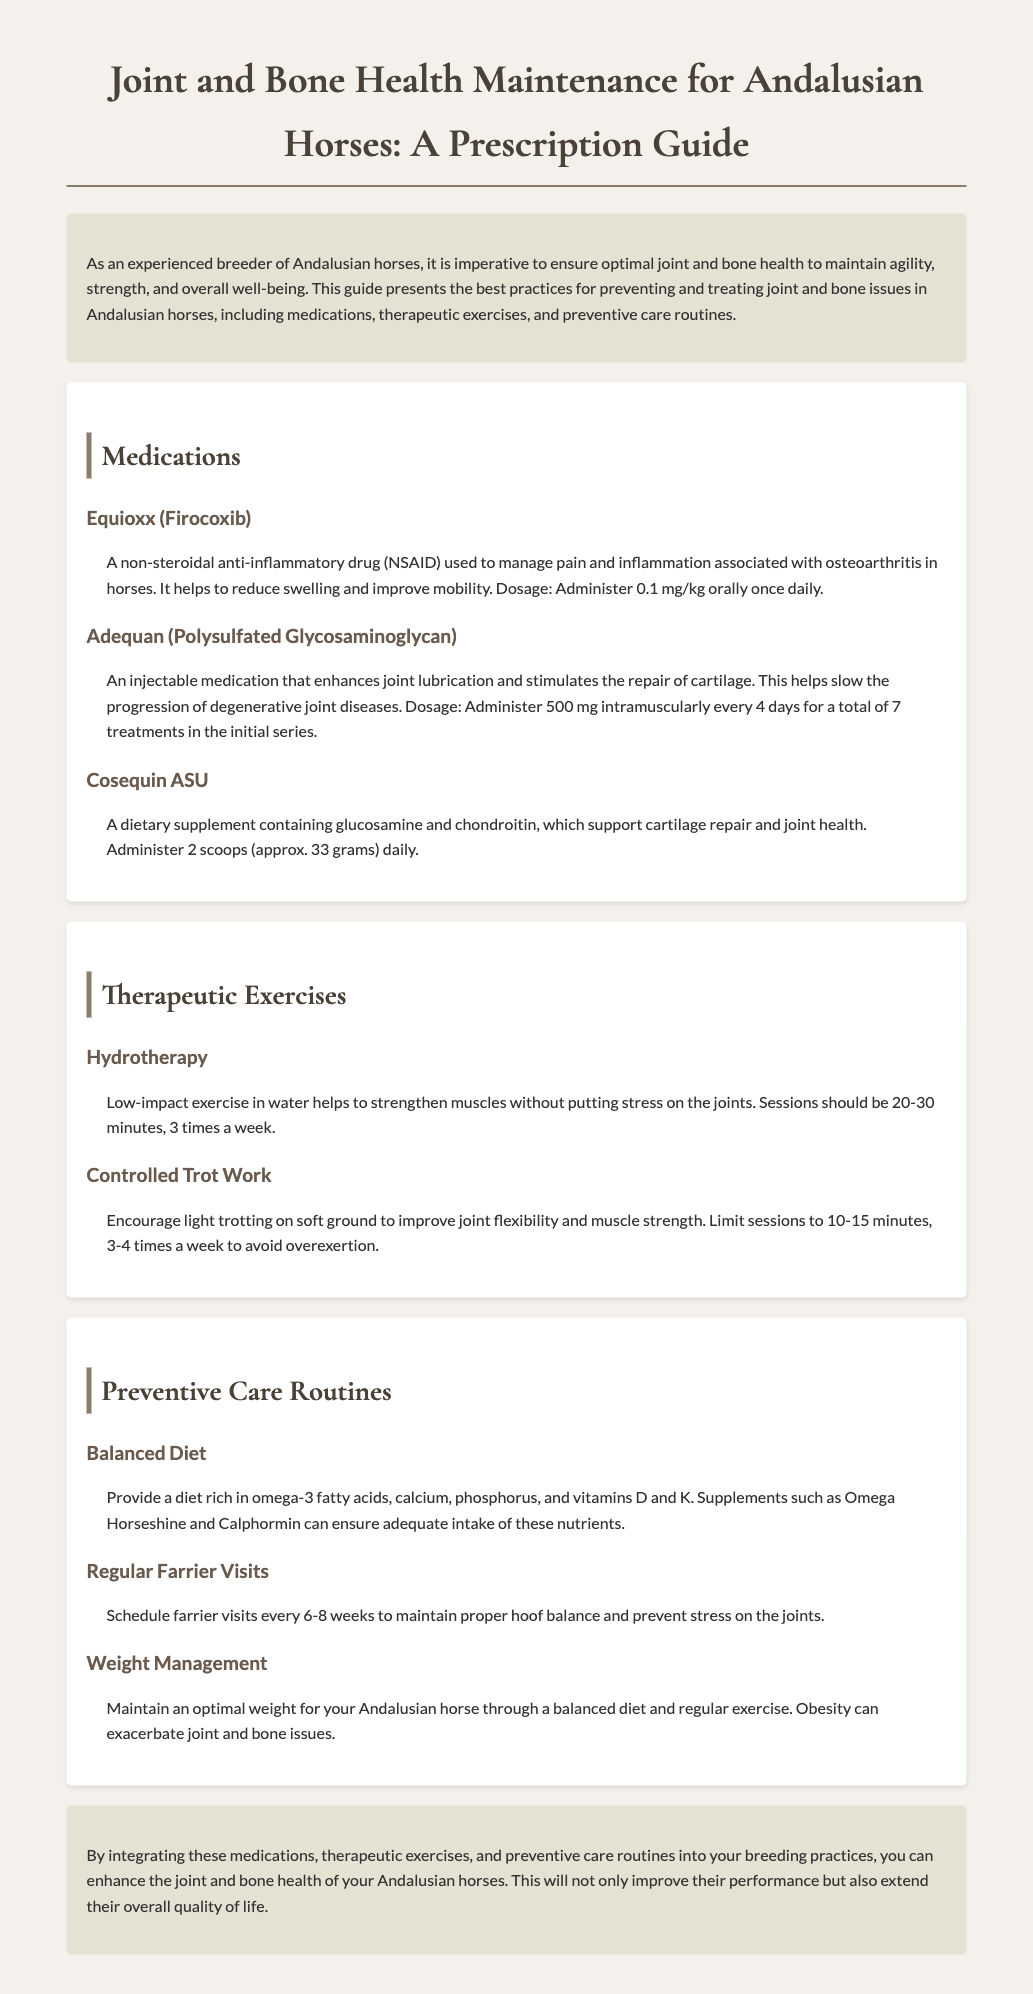What medication is used to manage pain and inflammation associated with osteoarthritis? The medication Equioxx (Firocoxib) is mentioned for managing pain and inflammation associated with osteoarthritis.
Answer: Equioxx (Firocoxib) How often should Adequan be administered during the initial treatment series? The document states that Adequan should be administered every 4 days for a total of 7 treatments in the initial series.
Answer: Every 4 days for 7 treatments What is the recommended dosage of Cosequin ASU? The document specifies the dosage of Cosequin ASU as 2 scoops (approx. 33 grams) daily.
Answer: 2 scoops daily How frequently should hydrotherapy sessions be performed? According to the therapeutic exercises section, hydrotherapy sessions should be performed 3 times a week.
Answer: 3 times a week What type of diet is suggested for optimal joint and bone health? The document recommends a diet rich in omega-3 fatty acids, calcium, phosphorus, and vitamins D and K.
Answer: Rich in omega-3s, calcium, phosphorus, vitamins D and K Why are regular farrier visits important? Regular farrier visits are important to maintain proper hoof balance and prevent stress on the joints.
Answer: To maintain proper hoof balance What is the impact of obesity on joint and bone issues? The document states that obesity can exacerbate joint and bone issues in horses.
Answer: Exacerbate joint and bone issues What is the total number of therapeutic exercises mentioned? There are two therapeutic exercises mentioned in the document for joint and bone health.
Answer: Two exercises What is the main purpose of this document? The main purpose of the document is to present best practices for preventing and treating joint and bone issues in Andalusian horses.
Answer: Preventing and treating joint and bone issues 